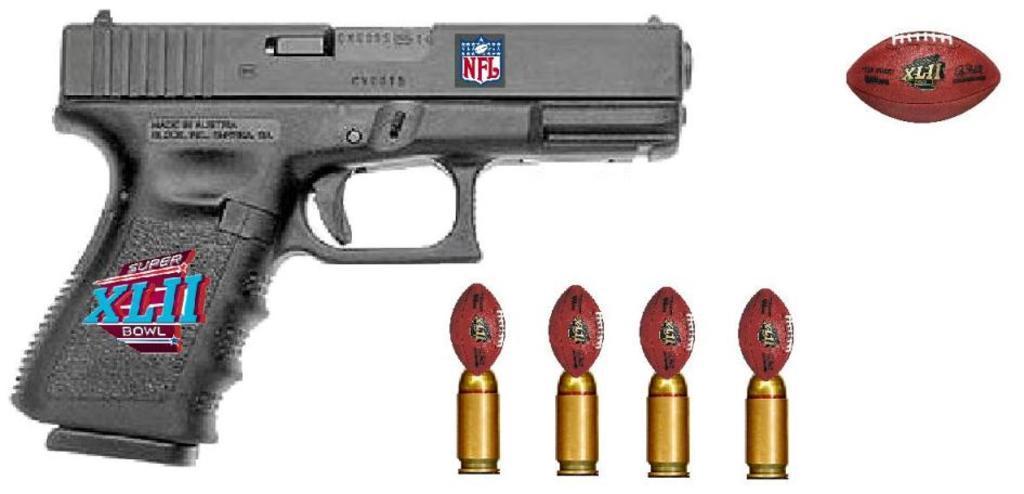Can you describe this image briefly? In this picture there is a gun and there are stickers on the gun and there is a text on the gun and there are bullets and there are balls on the bullets. On the right side of the image there is a ball and there is a text on the ball. 